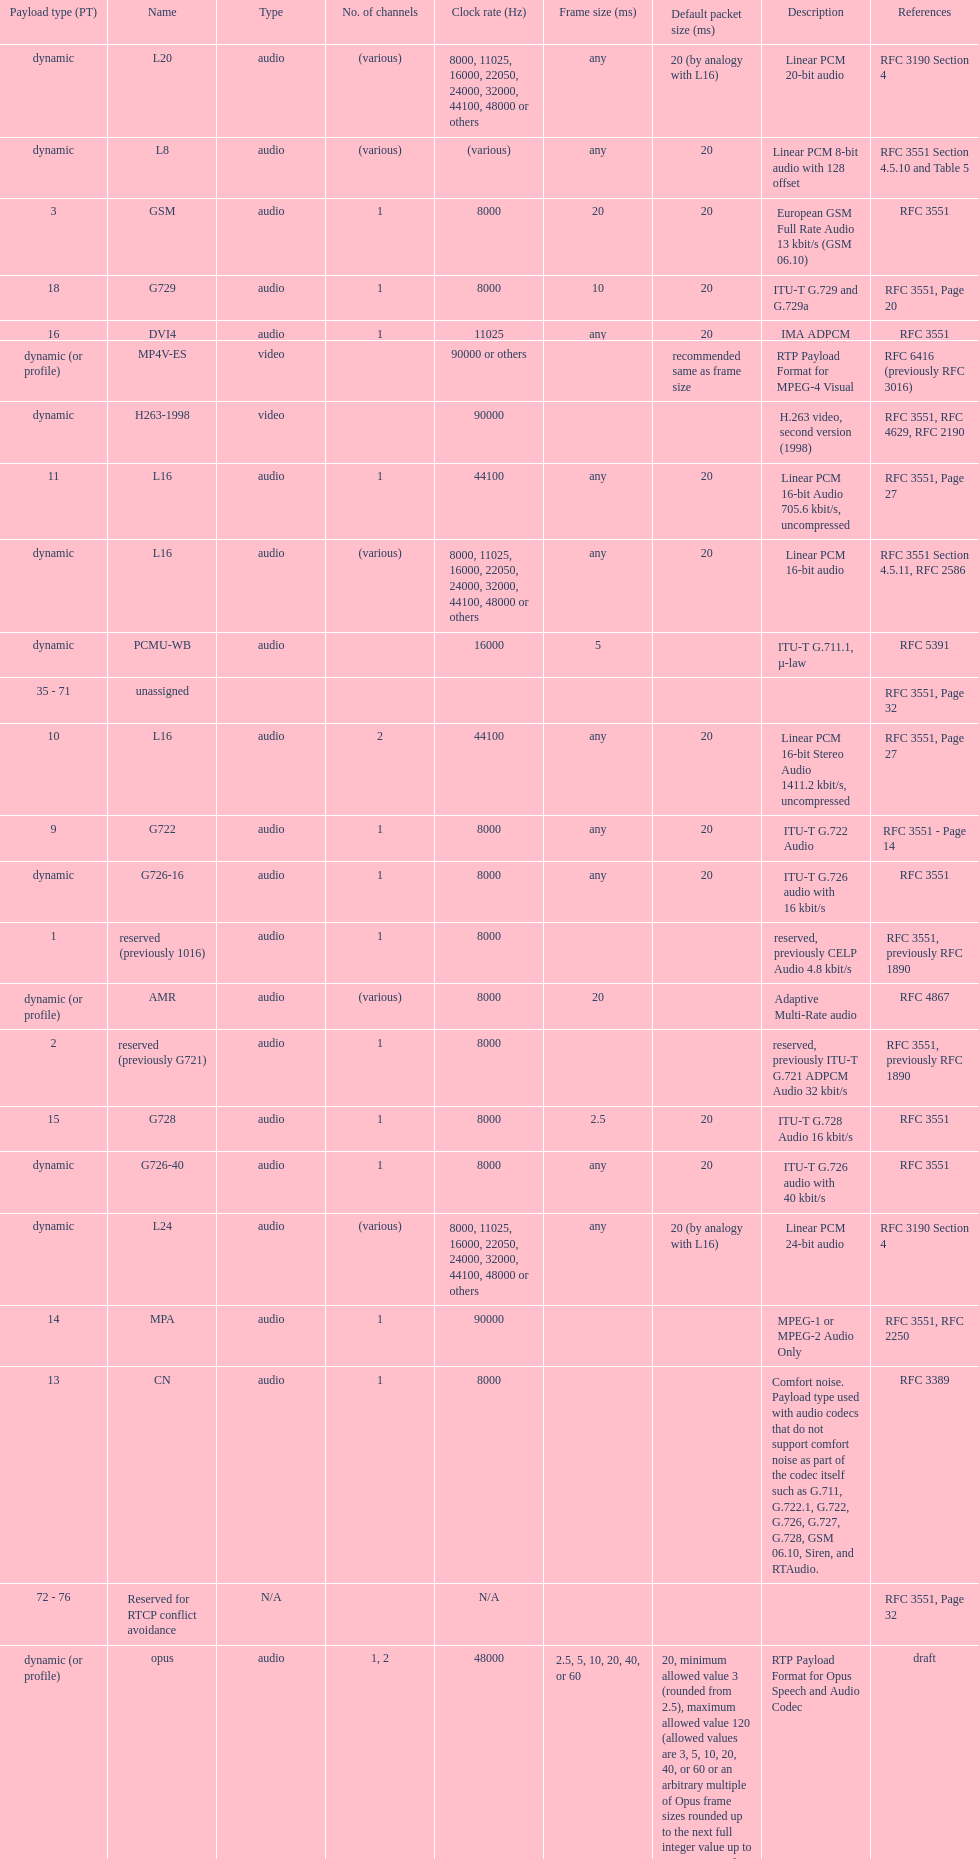What is the average number of channels? 1. 